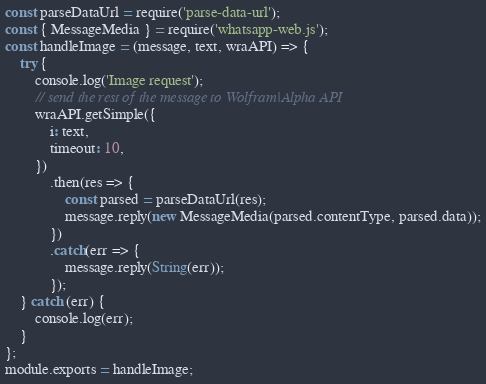Convert code to text. <code><loc_0><loc_0><loc_500><loc_500><_JavaScript_>const parseDataUrl = require('parse-data-url');
const { MessageMedia } = require('whatsapp-web.js');
const handleImage = (message, text, wraAPI) => {
	try {	
		console.log('Image request');
		// send the rest of the message to Wolfram|Alpha API
		wraAPI.getSimple({
			i: text,
			timeout: 10,
		})
			.then(res => {
                const parsed = parseDataUrl(res);
				message.reply(new MessageMedia(parsed.contentType, parsed.data));
			})
			.catch(err => {
				message.reply(String(err));
			});
	} catch (err) {
		console.log(err);
	}
};
module.exports = handleImage;</code> 